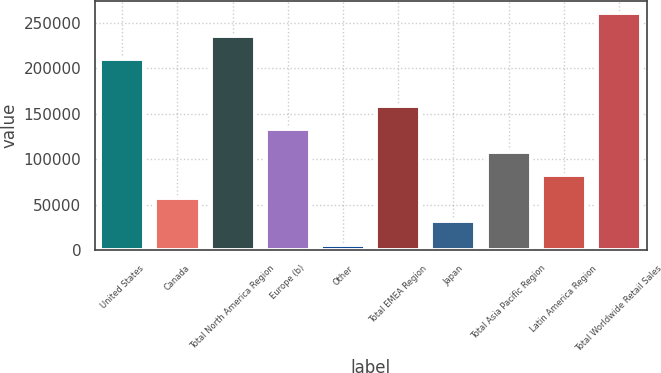<chart> <loc_0><loc_0><loc_500><loc_500><bar_chart><fcel>United States<fcel>Canada<fcel>Total North America Region<fcel>Europe (b)<fcel>Other<fcel>Total EMEA Region<fcel>Japan<fcel>Total Asia Pacific Region<fcel>Latin America Region<fcel>Total Worldwide Retail Sales<nl><fcel>209978<fcel>57394.2<fcel>235408<fcel>133686<fcel>6533<fcel>159117<fcel>31963.6<fcel>108255<fcel>82824.8<fcel>260839<nl></chart> 